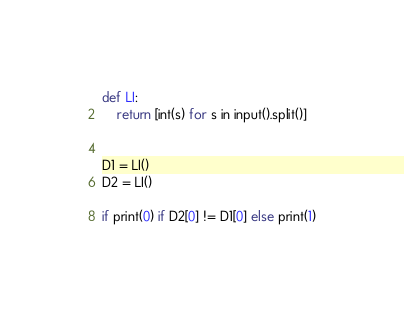Convert code to text. <code><loc_0><loc_0><loc_500><loc_500><_Python_>def LI:
	return [int(s) for s in input().split()]
  

D1 = LI()
D2 = LI()

if print(0) if D2[0] != D1[0] else print(1)</code> 